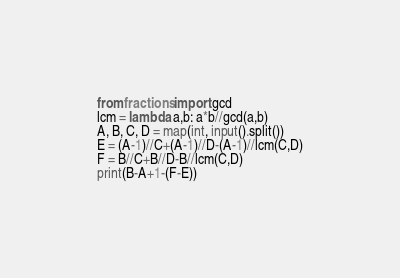<code> <loc_0><loc_0><loc_500><loc_500><_Python_>from fractions import gcd
lcm = lambda a,b: a*b//gcd(a,b)
A, B, C, D = map(int, input().split())
E = (A-1)//C+(A-1)//D-(A-1)//lcm(C,D)
F = B//C+B//D-B//lcm(C,D)
print(B-A+1-(F-E))</code> 